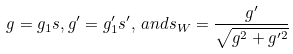Convert formula to latex. <formula><loc_0><loc_0><loc_500><loc_500>g = g _ { 1 } s , g ^ { \prime } = g _ { 1 } ^ { \prime } s ^ { \prime } , \, a n d s _ { W } = \frac { g ^ { \prime } } { \sqrt { g ^ { 2 } + g ^ { \prime 2 } } }</formula> 